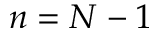Convert formula to latex. <formula><loc_0><loc_0><loc_500><loc_500>n = N - 1</formula> 